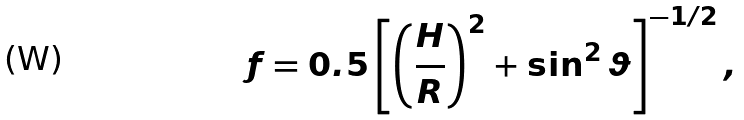Convert formula to latex. <formula><loc_0><loc_0><loc_500><loc_500>f = 0 . 5 \left [ \left ( \frac { H } { R } \right ) ^ { 2 } + \sin ^ { 2 } \vartheta \right ] ^ { - 1 / 2 } ,</formula> 